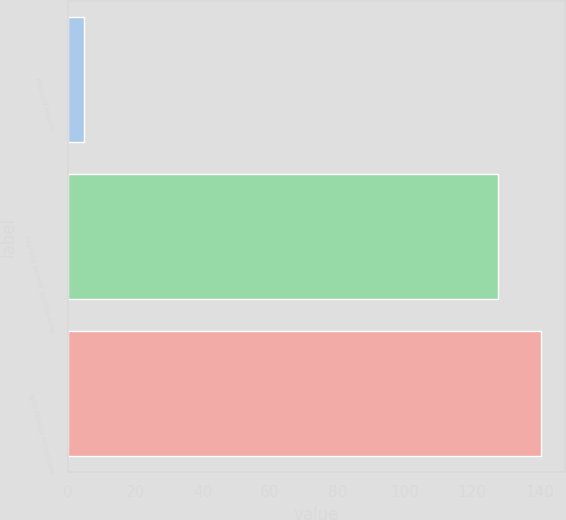<chart> <loc_0><loc_0><loc_500><loc_500><bar_chart><fcel>Accrued benefit<fcel>Accrued benefit liability-long<fcel>Total liability recognized<nl><fcel>4.9<fcel>127.6<fcel>140.36<nl></chart> 